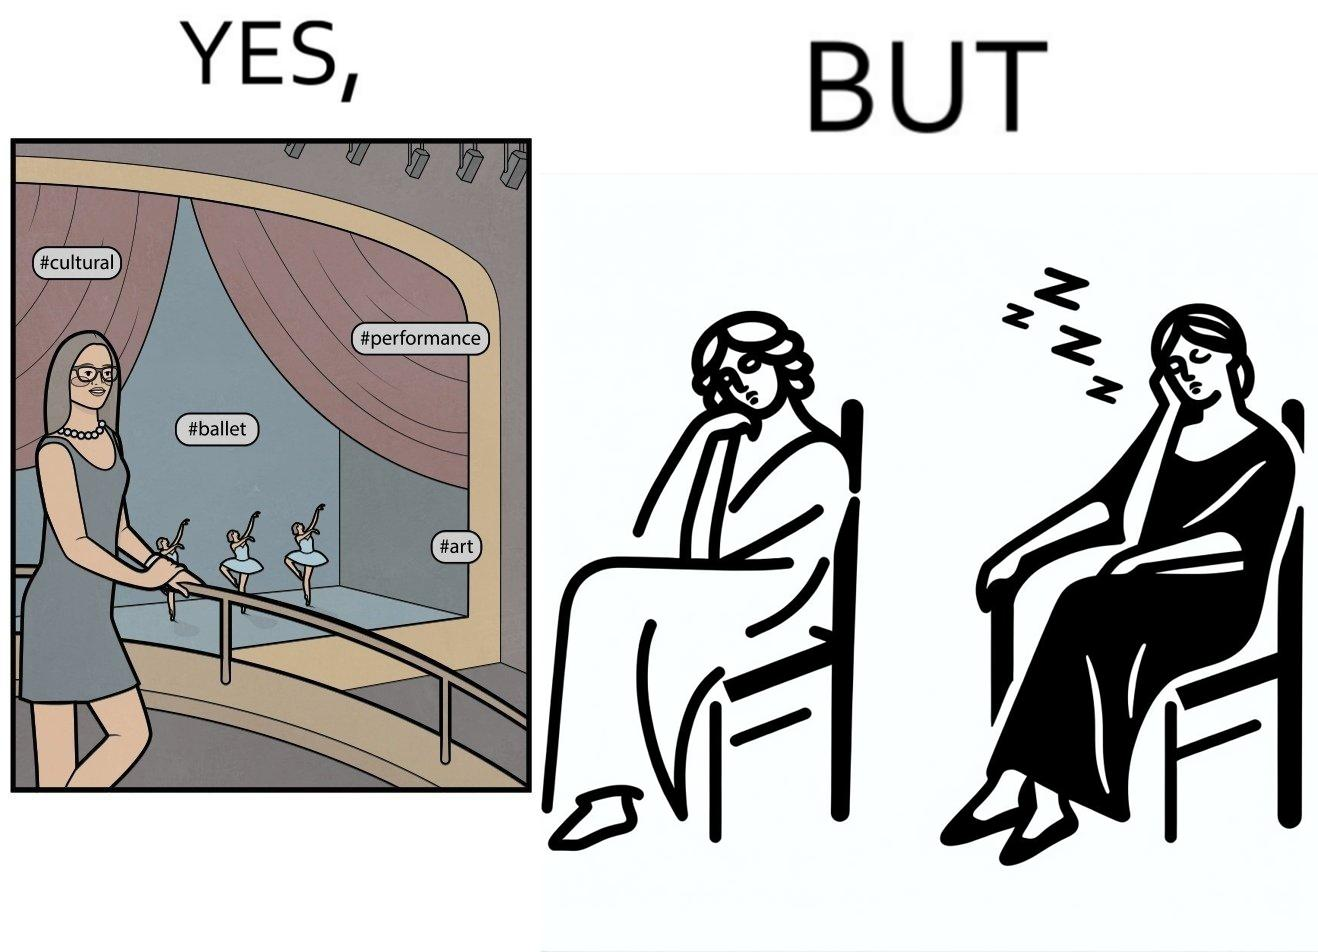Describe what you see in the left and right parts of this image. In the left part of the image: a woman standing with some pose for photo at any auditorium with some program going on in her background at the stage with some hashtags written on the image at different places In the right part of the image: a woman sitting on a chair and sleeping with her mouth open 